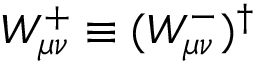<formula> <loc_0><loc_0><loc_500><loc_500>W _ { \mu \nu } ^ { + } \equiv ( W _ { \mu \nu } ^ { - } ) ^ { \dagger }</formula> 